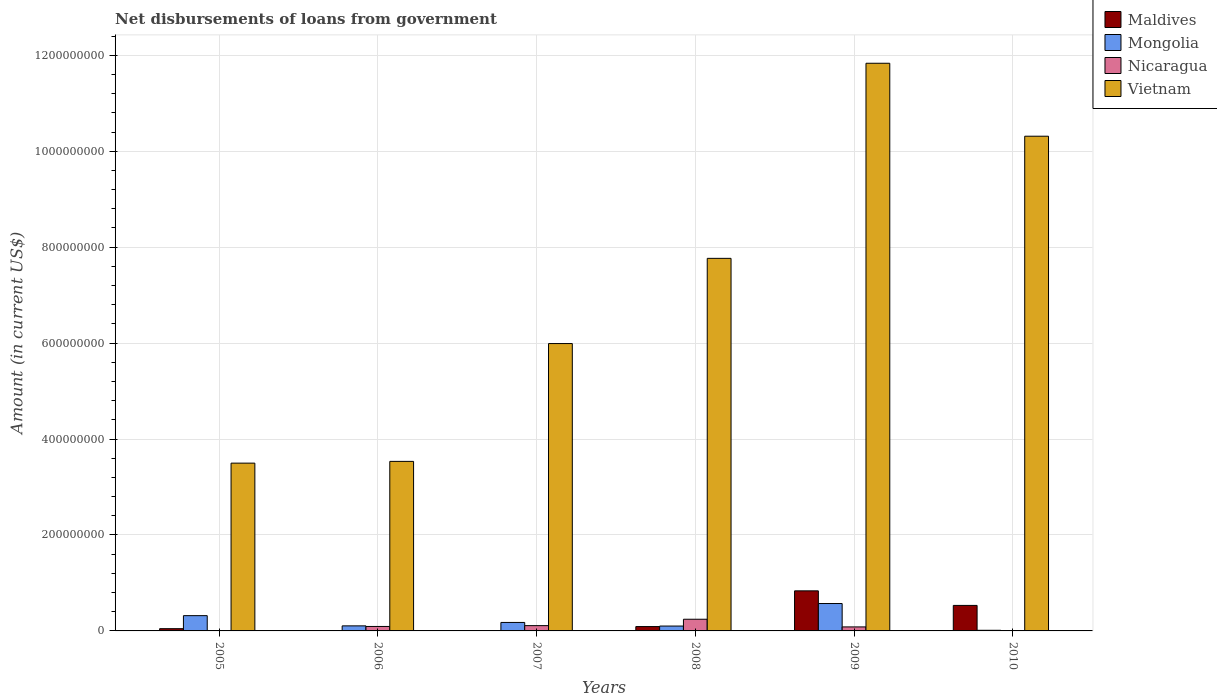How many groups of bars are there?
Ensure brevity in your answer.  6. Are the number of bars on each tick of the X-axis equal?
Your answer should be very brief. No. What is the label of the 4th group of bars from the left?
Your response must be concise. 2008. What is the amount of loan disbursed from government in Nicaragua in 2007?
Offer a very short reply. 1.10e+07. Across all years, what is the maximum amount of loan disbursed from government in Nicaragua?
Offer a very short reply. 2.43e+07. Across all years, what is the minimum amount of loan disbursed from government in Vietnam?
Give a very brief answer. 3.50e+08. What is the total amount of loan disbursed from government in Vietnam in the graph?
Give a very brief answer. 4.29e+09. What is the difference between the amount of loan disbursed from government in Maldives in 2005 and that in 2010?
Ensure brevity in your answer.  -4.85e+07. What is the difference between the amount of loan disbursed from government in Nicaragua in 2008 and the amount of loan disbursed from government in Vietnam in 2006?
Give a very brief answer. -3.29e+08. What is the average amount of loan disbursed from government in Vietnam per year?
Ensure brevity in your answer.  7.16e+08. In the year 2009, what is the difference between the amount of loan disbursed from government in Nicaragua and amount of loan disbursed from government in Vietnam?
Provide a succinct answer. -1.18e+09. In how many years, is the amount of loan disbursed from government in Mongolia greater than 440000000 US$?
Provide a short and direct response. 0. What is the ratio of the amount of loan disbursed from government in Vietnam in 2005 to that in 2007?
Offer a very short reply. 0.58. Is the amount of loan disbursed from government in Maldives in 2005 less than that in 2009?
Your answer should be compact. Yes. Is the difference between the amount of loan disbursed from government in Nicaragua in 2006 and 2009 greater than the difference between the amount of loan disbursed from government in Vietnam in 2006 and 2009?
Offer a terse response. Yes. What is the difference between the highest and the second highest amount of loan disbursed from government in Vietnam?
Make the answer very short. 1.52e+08. What is the difference between the highest and the lowest amount of loan disbursed from government in Maldives?
Ensure brevity in your answer.  8.35e+07. In how many years, is the amount of loan disbursed from government in Nicaragua greater than the average amount of loan disbursed from government in Nicaragua taken over all years?
Your answer should be compact. 3. Is it the case that in every year, the sum of the amount of loan disbursed from government in Vietnam and amount of loan disbursed from government in Nicaragua is greater than the sum of amount of loan disbursed from government in Mongolia and amount of loan disbursed from government in Maldives?
Give a very brief answer. No. How many bars are there?
Give a very brief answer. 20. Are all the bars in the graph horizontal?
Your answer should be very brief. No. What is the difference between two consecutive major ticks on the Y-axis?
Give a very brief answer. 2.00e+08. Are the values on the major ticks of Y-axis written in scientific E-notation?
Ensure brevity in your answer.  No. Does the graph contain any zero values?
Ensure brevity in your answer.  Yes. Does the graph contain grids?
Your response must be concise. Yes. Where does the legend appear in the graph?
Provide a short and direct response. Top right. What is the title of the graph?
Your answer should be very brief. Net disbursements of loans from government. What is the Amount (in current US$) of Maldives in 2005?
Offer a very short reply. 4.68e+06. What is the Amount (in current US$) in Mongolia in 2005?
Your answer should be compact. 3.18e+07. What is the Amount (in current US$) in Vietnam in 2005?
Offer a terse response. 3.50e+08. What is the Amount (in current US$) of Maldives in 2006?
Make the answer very short. 0. What is the Amount (in current US$) in Mongolia in 2006?
Ensure brevity in your answer.  1.05e+07. What is the Amount (in current US$) of Nicaragua in 2006?
Provide a short and direct response. 9.29e+06. What is the Amount (in current US$) in Vietnam in 2006?
Offer a terse response. 3.53e+08. What is the Amount (in current US$) in Mongolia in 2007?
Ensure brevity in your answer.  1.77e+07. What is the Amount (in current US$) in Nicaragua in 2007?
Your response must be concise. 1.10e+07. What is the Amount (in current US$) of Vietnam in 2007?
Provide a short and direct response. 5.99e+08. What is the Amount (in current US$) in Maldives in 2008?
Ensure brevity in your answer.  9.06e+06. What is the Amount (in current US$) of Mongolia in 2008?
Offer a very short reply. 1.02e+07. What is the Amount (in current US$) in Nicaragua in 2008?
Ensure brevity in your answer.  2.43e+07. What is the Amount (in current US$) of Vietnam in 2008?
Give a very brief answer. 7.77e+08. What is the Amount (in current US$) of Maldives in 2009?
Your response must be concise. 8.35e+07. What is the Amount (in current US$) in Mongolia in 2009?
Give a very brief answer. 5.71e+07. What is the Amount (in current US$) in Nicaragua in 2009?
Your answer should be very brief. 8.36e+06. What is the Amount (in current US$) in Vietnam in 2009?
Keep it short and to the point. 1.18e+09. What is the Amount (in current US$) in Maldives in 2010?
Offer a very short reply. 5.32e+07. What is the Amount (in current US$) of Mongolia in 2010?
Offer a terse response. 1.30e+06. What is the Amount (in current US$) in Vietnam in 2010?
Offer a terse response. 1.03e+09. Across all years, what is the maximum Amount (in current US$) of Maldives?
Make the answer very short. 8.35e+07. Across all years, what is the maximum Amount (in current US$) in Mongolia?
Offer a very short reply. 5.71e+07. Across all years, what is the maximum Amount (in current US$) of Nicaragua?
Make the answer very short. 2.43e+07. Across all years, what is the maximum Amount (in current US$) in Vietnam?
Offer a very short reply. 1.18e+09. Across all years, what is the minimum Amount (in current US$) of Mongolia?
Your answer should be compact. 1.30e+06. Across all years, what is the minimum Amount (in current US$) in Nicaragua?
Your answer should be compact. 0. Across all years, what is the minimum Amount (in current US$) of Vietnam?
Offer a terse response. 3.50e+08. What is the total Amount (in current US$) of Maldives in the graph?
Make the answer very short. 1.50e+08. What is the total Amount (in current US$) in Mongolia in the graph?
Offer a terse response. 1.29e+08. What is the total Amount (in current US$) in Nicaragua in the graph?
Offer a terse response. 5.30e+07. What is the total Amount (in current US$) of Vietnam in the graph?
Make the answer very short. 4.29e+09. What is the difference between the Amount (in current US$) of Mongolia in 2005 and that in 2006?
Your response must be concise. 2.13e+07. What is the difference between the Amount (in current US$) of Vietnam in 2005 and that in 2006?
Offer a very short reply. -3.66e+06. What is the difference between the Amount (in current US$) in Mongolia in 2005 and that in 2007?
Make the answer very short. 1.42e+07. What is the difference between the Amount (in current US$) in Vietnam in 2005 and that in 2007?
Give a very brief answer. -2.49e+08. What is the difference between the Amount (in current US$) of Maldives in 2005 and that in 2008?
Offer a terse response. -4.38e+06. What is the difference between the Amount (in current US$) in Mongolia in 2005 and that in 2008?
Provide a succinct answer. 2.17e+07. What is the difference between the Amount (in current US$) of Vietnam in 2005 and that in 2008?
Provide a short and direct response. -4.27e+08. What is the difference between the Amount (in current US$) in Maldives in 2005 and that in 2009?
Keep it short and to the point. -7.88e+07. What is the difference between the Amount (in current US$) in Mongolia in 2005 and that in 2009?
Give a very brief answer. -2.53e+07. What is the difference between the Amount (in current US$) of Vietnam in 2005 and that in 2009?
Provide a succinct answer. -8.34e+08. What is the difference between the Amount (in current US$) in Maldives in 2005 and that in 2010?
Your response must be concise. -4.85e+07. What is the difference between the Amount (in current US$) in Mongolia in 2005 and that in 2010?
Give a very brief answer. 3.05e+07. What is the difference between the Amount (in current US$) of Vietnam in 2005 and that in 2010?
Give a very brief answer. -6.82e+08. What is the difference between the Amount (in current US$) in Mongolia in 2006 and that in 2007?
Your answer should be compact. -7.15e+06. What is the difference between the Amount (in current US$) in Nicaragua in 2006 and that in 2007?
Offer a terse response. -1.73e+06. What is the difference between the Amount (in current US$) of Vietnam in 2006 and that in 2007?
Your answer should be compact. -2.46e+08. What is the difference between the Amount (in current US$) of Mongolia in 2006 and that in 2008?
Provide a succinct answer. 3.77e+05. What is the difference between the Amount (in current US$) in Nicaragua in 2006 and that in 2008?
Keep it short and to the point. -1.50e+07. What is the difference between the Amount (in current US$) of Vietnam in 2006 and that in 2008?
Your answer should be very brief. -4.23e+08. What is the difference between the Amount (in current US$) in Mongolia in 2006 and that in 2009?
Keep it short and to the point. -4.66e+07. What is the difference between the Amount (in current US$) in Nicaragua in 2006 and that in 2009?
Keep it short and to the point. 9.23e+05. What is the difference between the Amount (in current US$) of Vietnam in 2006 and that in 2009?
Your answer should be compact. -8.30e+08. What is the difference between the Amount (in current US$) of Mongolia in 2006 and that in 2010?
Make the answer very short. 9.22e+06. What is the difference between the Amount (in current US$) of Vietnam in 2006 and that in 2010?
Provide a succinct answer. -6.78e+08. What is the difference between the Amount (in current US$) of Mongolia in 2007 and that in 2008?
Your response must be concise. 7.53e+06. What is the difference between the Amount (in current US$) of Nicaragua in 2007 and that in 2008?
Ensure brevity in your answer.  -1.33e+07. What is the difference between the Amount (in current US$) of Vietnam in 2007 and that in 2008?
Provide a short and direct response. -1.78e+08. What is the difference between the Amount (in current US$) of Mongolia in 2007 and that in 2009?
Offer a terse response. -3.94e+07. What is the difference between the Amount (in current US$) of Nicaragua in 2007 and that in 2009?
Ensure brevity in your answer.  2.65e+06. What is the difference between the Amount (in current US$) of Vietnam in 2007 and that in 2009?
Your response must be concise. -5.84e+08. What is the difference between the Amount (in current US$) in Mongolia in 2007 and that in 2010?
Your answer should be compact. 1.64e+07. What is the difference between the Amount (in current US$) in Vietnam in 2007 and that in 2010?
Make the answer very short. -4.32e+08. What is the difference between the Amount (in current US$) of Maldives in 2008 and that in 2009?
Give a very brief answer. -7.45e+07. What is the difference between the Amount (in current US$) in Mongolia in 2008 and that in 2009?
Your answer should be very brief. -4.70e+07. What is the difference between the Amount (in current US$) of Nicaragua in 2008 and that in 2009?
Provide a short and direct response. 1.60e+07. What is the difference between the Amount (in current US$) of Vietnam in 2008 and that in 2009?
Your answer should be very brief. -4.07e+08. What is the difference between the Amount (in current US$) in Maldives in 2008 and that in 2010?
Give a very brief answer. -4.41e+07. What is the difference between the Amount (in current US$) in Mongolia in 2008 and that in 2010?
Give a very brief answer. 8.85e+06. What is the difference between the Amount (in current US$) in Vietnam in 2008 and that in 2010?
Offer a very short reply. -2.55e+08. What is the difference between the Amount (in current US$) of Maldives in 2009 and that in 2010?
Ensure brevity in your answer.  3.04e+07. What is the difference between the Amount (in current US$) in Mongolia in 2009 and that in 2010?
Offer a very short reply. 5.58e+07. What is the difference between the Amount (in current US$) in Vietnam in 2009 and that in 2010?
Keep it short and to the point. 1.52e+08. What is the difference between the Amount (in current US$) in Maldives in 2005 and the Amount (in current US$) in Mongolia in 2006?
Your answer should be compact. -5.84e+06. What is the difference between the Amount (in current US$) of Maldives in 2005 and the Amount (in current US$) of Nicaragua in 2006?
Keep it short and to the point. -4.60e+06. What is the difference between the Amount (in current US$) in Maldives in 2005 and the Amount (in current US$) in Vietnam in 2006?
Make the answer very short. -3.49e+08. What is the difference between the Amount (in current US$) in Mongolia in 2005 and the Amount (in current US$) in Nicaragua in 2006?
Offer a terse response. 2.26e+07. What is the difference between the Amount (in current US$) of Mongolia in 2005 and the Amount (in current US$) of Vietnam in 2006?
Your response must be concise. -3.22e+08. What is the difference between the Amount (in current US$) in Maldives in 2005 and the Amount (in current US$) in Mongolia in 2007?
Offer a terse response. -1.30e+07. What is the difference between the Amount (in current US$) in Maldives in 2005 and the Amount (in current US$) in Nicaragua in 2007?
Your answer should be compact. -6.33e+06. What is the difference between the Amount (in current US$) of Maldives in 2005 and the Amount (in current US$) of Vietnam in 2007?
Your answer should be very brief. -5.94e+08. What is the difference between the Amount (in current US$) of Mongolia in 2005 and the Amount (in current US$) of Nicaragua in 2007?
Provide a succinct answer. 2.08e+07. What is the difference between the Amount (in current US$) in Mongolia in 2005 and the Amount (in current US$) in Vietnam in 2007?
Your answer should be compact. -5.67e+08. What is the difference between the Amount (in current US$) of Maldives in 2005 and the Amount (in current US$) of Mongolia in 2008?
Provide a succinct answer. -5.47e+06. What is the difference between the Amount (in current US$) of Maldives in 2005 and the Amount (in current US$) of Nicaragua in 2008?
Give a very brief answer. -1.96e+07. What is the difference between the Amount (in current US$) in Maldives in 2005 and the Amount (in current US$) in Vietnam in 2008?
Offer a terse response. -7.72e+08. What is the difference between the Amount (in current US$) in Mongolia in 2005 and the Amount (in current US$) in Nicaragua in 2008?
Offer a very short reply. 7.52e+06. What is the difference between the Amount (in current US$) in Mongolia in 2005 and the Amount (in current US$) in Vietnam in 2008?
Ensure brevity in your answer.  -7.45e+08. What is the difference between the Amount (in current US$) in Maldives in 2005 and the Amount (in current US$) in Mongolia in 2009?
Offer a very short reply. -5.24e+07. What is the difference between the Amount (in current US$) in Maldives in 2005 and the Amount (in current US$) in Nicaragua in 2009?
Offer a very short reply. -3.68e+06. What is the difference between the Amount (in current US$) of Maldives in 2005 and the Amount (in current US$) of Vietnam in 2009?
Your response must be concise. -1.18e+09. What is the difference between the Amount (in current US$) of Mongolia in 2005 and the Amount (in current US$) of Nicaragua in 2009?
Provide a short and direct response. 2.35e+07. What is the difference between the Amount (in current US$) in Mongolia in 2005 and the Amount (in current US$) in Vietnam in 2009?
Provide a succinct answer. -1.15e+09. What is the difference between the Amount (in current US$) in Maldives in 2005 and the Amount (in current US$) in Mongolia in 2010?
Make the answer very short. 3.38e+06. What is the difference between the Amount (in current US$) in Maldives in 2005 and the Amount (in current US$) in Vietnam in 2010?
Ensure brevity in your answer.  -1.03e+09. What is the difference between the Amount (in current US$) in Mongolia in 2005 and the Amount (in current US$) in Vietnam in 2010?
Give a very brief answer. -9.99e+08. What is the difference between the Amount (in current US$) in Mongolia in 2006 and the Amount (in current US$) in Nicaragua in 2007?
Provide a succinct answer. -4.81e+05. What is the difference between the Amount (in current US$) of Mongolia in 2006 and the Amount (in current US$) of Vietnam in 2007?
Your answer should be compact. -5.89e+08. What is the difference between the Amount (in current US$) in Nicaragua in 2006 and the Amount (in current US$) in Vietnam in 2007?
Provide a succinct answer. -5.90e+08. What is the difference between the Amount (in current US$) in Mongolia in 2006 and the Amount (in current US$) in Nicaragua in 2008?
Provide a short and direct response. -1.38e+07. What is the difference between the Amount (in current US$) in Mongolia in 2006 and the Amount (in current US$) in Vietnam in 2008?
Make the answer very short. -7.66e+08. What is the difference between the Amount (in current US$) of Nicaragua in 2006 and the Amount (in current US$) of Vietnam in 2008?
Offer a very short reply. -7.67e+08. What is the difference between the Amount (in current US$) of Mongolia in 2006 and the Amount (in current US$) of Nicaragua in 2009?
Provide a succinct answer. 2.17e+06. What is the difference between the Amount (in current US$) in Mongolia in 2006 and the Amount (in current US$) in Vietnam in 2009?
Give a very brief answer. -1.17e+09. What is the difference between the Amount (in current US$) in Nicaragua in 2006 and the Amount (in current US$) in Vietnam in 2009?
Give a very brief answer. -1.17e+09. What is the difference between the Amount (in current US$) of Mongolia in 2006 and the Amount (in current US$) of Vietnam in 2010?
Your response must be concise. -1.02e+09. What is the difference between the Amount (in current US$) in Nicaragua in 2006 and the Amount (in current US$) in Vietnam in 2010?
Your response must be concise. -1.02e+09. What is the difference between the Amount (in current US$) of Mongolia in 2007 and the Amount (in current US$) of Nicaragua in 2008?
Offer a very short reply. -6.65e+06. What is the difference between the Amount (in current US$) of Mongolia in 2007 and the Amount (in current US$) of Vietnam in 2008?
Keep it short and to the point. -7.59e+08. What is the difference between the Amount (in current US$) in Nicaragua in 2007 and the Amount (in current US$) in Vietnam in 2008?
Offer a terse response. -7.66e+08. What is the difference between the Amount (in current US$) of Mongolia in 2007 and the Amount (in current US$) of Nicaragua in 2009?
Your response must be concise. 9.32e+06. What is the difference between the Amount (in current US$) of Mongolia in 2007 and the Amount (in current US$) of Vietnam in 2009?
Give a very brief answer. -1.17e+09. What is the difference between the Amount (in current US$) of Nicaragua in 2007 and the Amount (in current US$) of Vietnam in 2009?
Keep it short and to the point. -1.17e+09. What is the difference between the Amount (in current US$) of Mongolia in 2007 and the Amount (in current US$) of Vietnam in 2010?
Your response must be concise. -1.01e+09. What is the difference between the Amount (in current US$) in Nicaragua in 2007 and the Amount (in current US$) in Vietnam in 2010?
Provide a short and direct response. -1.02e+09. What is the difference between the Amount (in current US$) in Maldives in 2008 and the Amount (in current US$) in Mongolia in 2009?
Give a very brief answer. -4.80e+07. What is the difference between the Amount (in current US$) of Maldives in 2008 and the Amount (in current US$) of Nicaragua in 2009?
Provide a succinct answer. 7.02e+05. What is the difference between the Amount (in current US$) in Maldives in 2008 and the Amount (in current US$) in Vietnam in 2009?
Your answer should be compact. -1.17e+09. What is the difference between the Amount (in current US$) of Mongolia in 2008 and the Amount (in current US$) of Nicaragua in 2009?
Offer a terse response. 1.79e+06. What is the difference between the Amount (in current US$) in Mongolia in 2008 and the Amount (in current US$) in Vietnam in 2009?
Your answer should be compact. -1.17e+09. What is the difference between the Amount (in current US$) of Nicaragua in 2008 and the Amount (in current US$) of Vietnam in 2009?
Your answer should be very brief. -1.16e+09. What is the difference between the Amount (in current US$) of Maldives in 2008 and the Amount (in current US$) of Mongolia in 2010?
Ensure brevity in your answer.  7.76e+06. What is the difference between the Amount (in current US$) of Maldives in 2008 and the Amount (in current US$) of Vietnam in 2010?
Your answer should be very brief. -1.02e+09. What is the difference between the Amount (in current US$) in Mongolia in 2008 and the Amount (in current US$) in Vietnam in 2010?
Make the answer very short. -1.02e+09. What is the difference between the Amount (in current US$) of Nicaragua in 2008 and the Amount (in current US$) of Vietnam in 2010?
Keep it short and to the point. -1.01e+09. What is the difference between the Amount (in current US$) of Maldives in 2009 and the Amount (in current US$) of Mongolia in 2010?
Provide a short and direct response. 8.22e+07. What is the difference between the Amount (in current US$) of Maldives in 2009 and the Amount (in current US$) of Vietnam in 2010?
Your answer should be very brief. -9.48e+08. What is the difference between the Amount (in current US$) in Mongolia in 2009 and the Amount (in current US$) in Vietnam in 2010?
Give a very brief answer. -9.74e+08. What is the difference between the Amount (in current US$) of Nicaragua in 2009 and the Amount (in current US$) of Vietnam in 2010?
Offer a terse response. -1.02e+09. What is the average Amount (in current US$) of Maldives per year?
Provide a succinct answer. 2.51e+07. What is the average Amount (in current US$) in Mongolia per year?
Keep it short and to the point. 2.14e+07. What is the average Amount (in current US$) in Nicaragua per year?
Give a very brief answer. 8.83e+06. What is the average Amount (in current US$) of Vietnam per year?
Your answer should be compact. 7.16e+08. In the year 2005, what is the difference between the Amount (in current US$) of Maldives and Amount (in current US$) of Mongolia?
Your response must be concise. -2.72e+07. In the year 2005, what is the difference between the Amount (in current US$) of Maldives and Amount (in current US$) of Vietnam?
Offer a terse response. -3.45e+08. In the year 2005, what is the difference between the Amount (in current US$) of Mongolia and Amount (in current US$) of Vietnam?
Provide a succinct answer. -3.18e+08. In the year 2006, what is the difference between the Amount (in current US$) of Mongolia and Amount (in current US$) of Nicaragua?
Your answer should be very brief. 1.24e+06. In the year 2006, what is the difference between the Amount (in current US$) in Mongolia and Amount (in current US$) in Vietnam?
Provide a short and direct response. -3.43e+08. In the year 2006, what is the difference between the Amount (in current US$) of Nicaragua and Amount (in current US$) of Vietnam?
Provide a short and direct response. -3.44e+08. In the year 2007, what is the difference between the Amount (in current US$) of Mongolia and Amount (in current US$) of Nicaragua?
Keep it short and to the point. 6.67e+06. In the year 2007, what is the difference between the Amount (in current US$) of Mongolia and Amount (in current US$) of Vietnam?
Give a very brief answer. -5.81e+08. In the year 2007, what is the difference between the Amount (in current US$) of Nicaragua and Amount (in current US$) of Vietnam?
Offer a very short reply. -5.88e+08. In the year 2008, what is the difference between the Amount (in current US$) of Maldives and Amount (in current US$) of Mongolia?
Ensure brevity in your answer.  -1.09e+06. In the year 2008, what is the difference between the Amount (in current US$) in Maldives and Amount (in current US$) in Nicaragua?
Offer a very short reply. -1.53e+07. In the year 2008, what is the difference between the Amount (in current US$) in Maldives and Amount (in current US$) in Vietnam?
Ensure brevity in your answer.  -7.68e+08. In the year 2008, what is the difference between the Amount (in current US$) of Mongolia and Amount (in current US$) of Nicaragua?
Offer a terse response. -1.42e+07. In the year 2008, what is the difference between the Amount (in current US$) of Mongolia and Amount (in current US$) of Vietnam?
Ensure brevity in your answer.  -7.67e+08. In the year 2008, what is the difference between the Amount (in current US$) of Nicaragua and Amount (in current US$) of Vietnam?
Your response must be concise. -7.52e+08. In the year 2009, what is the difference between the Amount (in current US$) of Maldives and Amount (in current US$) of Mongolia?
Offer a terse response. 2.64e+07. In the year 2009, what is the difference between the Amount (in current US$) of Maldives and Amount (in current US$) of Nicaragua?
Your answer should be compact. 7.52e+07. In the year 2009, what is the difference between the Amount (in current US$) in Maldives and Amount (in current US$) in Vietnam?
Offer a very short reply. -1.10e+09. In the year 2009, what is the difference between the Amount (in current US$) of Mongolia and Amount (in current US$) of Nicaragua?
Make the answer very short. 4.87e+07. In the year 2009, what is the difference between the Amount (in current US$) in Mongolia and Amount (in current US$) in Vietnam?
Your answer should be very brief. -1.13e+09. In the year 2009, what is the difference between the Amount (in current US$) in Nicaragua and Amount (in current US$) in Vietnam?
Keep it short and to the point. -1.18e+09. In the year 2010, what is the difference between the Amount (in current US$) of Maldives and Amount (in current US$) of Mongolia?
Offer a terse response. 5.19e+07. In the year 2010, what is the difference between the Amount (in current US$) of Maldives and Amount (in current US$) of Vietnam?
Ensure brevity in your answer.  -9.78e+08. In the year 2010, what is the difference between the Amount (in current US$) of Mongolia and Amount (in current US$) of Vietnam?
Keep it short and to the point. -1.03e+09. What is the ratio of the Amount (in current US$) in Mongolia in 2005 to that in 2006?
Your answer should be very brief. 3.02. What is the ratio of the Amount (in current US$) in Vietnam in 2005 to that in 2006?
Your response must be concise. 0.99. What is the ratio of the Amount (in current US$) of Mongolia in 2005 to that in 2007?
Give a very brief answer. 1.8. What is the ratio of the Amount (in current US$) of Vietnam in 2005 to that in 2007?
Give a very brief answer. 0.58. What is the ratio of the Amount (in current US$) in Maldives in 2005 to that in 2008?
Provide a short and direct response. 0.52. What is the ratio of the Amount (in current US$) in Mongolia in 2005 to that in 2008?
Ensure brevity in your answer.  3.14. What is the ratio of the Amount (in current US$) in Vietnam in 2005 to that in 2008?
Ensure brevity in your answer.  0.45. What is the ratio of the Amount (in current US$) in Maldives in 2005 to that in 2009?
Your response must be concise. 0.06. What is the ratio of the Amount (in current US$) of Mongolia in 2005 to that in 2009?
Your answer should be compact. 0.56. What is the ratio of the Amount (in current US$) in Vietnam in 2005 to that in 2009?
Make the answer very short. 0.3. What is the ratio of the Amount (in current US$) in Maldives in 2005 to that in 2010?
Your answer should be compact. 0.09. What is the ratio of the Amount (in current US$) in Mongolia in 2005 to that in 2010?
Give a very brief answer. 24.4. What is the ratio of the Amount (in current US$) of Vietnam in 2005 to that in 2010?
Provide a succinct answer. 0.34. What is the ratio of the Amount (in current US$) of Mongolia in 2006 to that in 2007?
Ensure brevity in your answer.  0.6. What is the ratio of the Amount (in current US$) of Nicaragua in 2006 to that in 2007?
Offer a terse response. 0.84. What is the ratio of the Amount (in current US$) in Vietnam in 2006 to that in 2007?
Your response must be concise. 0.59. What is the ratio of the Amount (in current US$) in Mongolia in 2006 to that in 2008?
Offer a terse response. 1.04. What is the ratio of the Amount (in current US$) in Nicaragua in 2006 to that in 2008?
Your response must be concise. 0.38. What is the ratio of the Amount (in current US$) of Vietnam in 2006 to that in 2008?
Your answer should be very brief. 0.46. What is the ratio of the Amount (in current US$) of Mongolia in 2006 to that in 2009?
Your answer should be very brief. 0.18. What is the ratio of the Amount (in current US$) in Nicaragua in 2006 to that in 2009?
Your response must be concise. 1.11. What is the ratio of the Amount (in current US$) of Vietnam in 2006 to that in 2009?
Ensure brevity in your answer.  0.3. What is the ratio of the Amount (in current US$) in Mongolia in 2006 to that in 2010?
Provide a succinct answer. 8.07. What is the ratio of the Amount (in current US$) of Vietnam in 2006 to that in 2010?
Your answer should be compact. 0.34. What is the ratio of the Amount (in current US$) of Mongolia in 2007 to that in 2008?
Offer a terse response. 1.74. What is the ratio of the Amount (in current US$) of Nicaragua in 2007 to that in 2008?
Provide a short and direct response. 0.45. What is the ratio of the Amount (in current US$) in Vietnam in 2007 to that in 2008?
Give a very brief answer. 0.77. What is the ratio of the Amount (in current US$) in Mongolia in 2007 to that in 2009?
Offer a terse response. 0.31. What is the ratio of the Amount (in current US$) in Nicaragua in 2007 to that in 2009?
Provide a succinct answer. 1.32. What is the ratio of the Amount (in current US$) of Vietnam in 2007 to that in 2009?
Provide a succinct answer. 0.51. What is the ratio of the Amount (in current US$) of Mongolia in 2007 to that in 2010?
Offer a terse response. 13.55. What is the ratio of the Amount (in current US$) of Vietnam in 2007 to that in 2010?
Your answer should be compact. 0.58. What is the ratio of the Amount (in current US$) in Maldives in 2008 to that in 2009?
Make the answer very short. 0.11. What is the ratio of the Amount (in current US$) in Mongolia in 2008 to that in 2009?
Ensure brevity in your answer.  0.18. What is the ratio of the Amount (in current US$) of Nicaragua in 2008 to that in 2009?
Give a very brief answer. 2.91. What is the ratio of the Amount (in current US$) of Vietnam in 2008 to that in 2009?
Your answer should be very brief. 0.66. What is the ratio of the Amount (in current US$) in Maldives in 2008 to that in 2010?
Provide a succinct answer. 0.17. What is the ratio of the Amount (in current US$) of Mongolia in 2008 to that in 2010?
Give a very brief answer. 7.78. What is the ratio of the Amount (in current US$) of Vietnam in 2008 to that in 2010?
Provide a short and direct response. 0.75. What is the ratio of the Amount (in current US$) of Maldives in 2009 to that in 2010?
Offer a terse response. 1.57. What is the ratio of the Amount (in current US$) of Mongolia in 2009 to that in 2010?
Give a very brief answer. 43.76. What is the ratio of the Amount (in current US$) in Vietnam in 2009 to that in 2010?
Your answer should be very brief. 1.15. What is the difference between the highest and the second highest Amount (in current US$) of Maldives?
Ensure brevity in your answer.  3.04e+07. What is the difference between the highest and the second highest Amount (in current US$) of Mongolia?
Offer a terse response. 2.53e+07. What is the difference between the highest and the second highest Amount (in current US$) of Nicaragua?
Your answer should be compact. 1.33e+07. What is the difference between the highest and the second highest Amount (in current US$) of Vietnam?
Offer a terse response. 1.52e+08. What is the difference between the highest and the lowest Amount (in current US$) of Maldives?
Keep it short and to the point. 8.35e+07. What is the difference between the highest and the lowest Amount (in current US$) in Mongolia?
Give a very brief answer. 5.58e+07. What is the difference between the highest and the lowest Amount (in current US$) of Nicaragua?
Give a very brief answer. 2.43e+07. What is the difference between the highest and the lowest Amount (in current US$) of Vietnam?
Your answer should be very brief. 8.34e+08. 